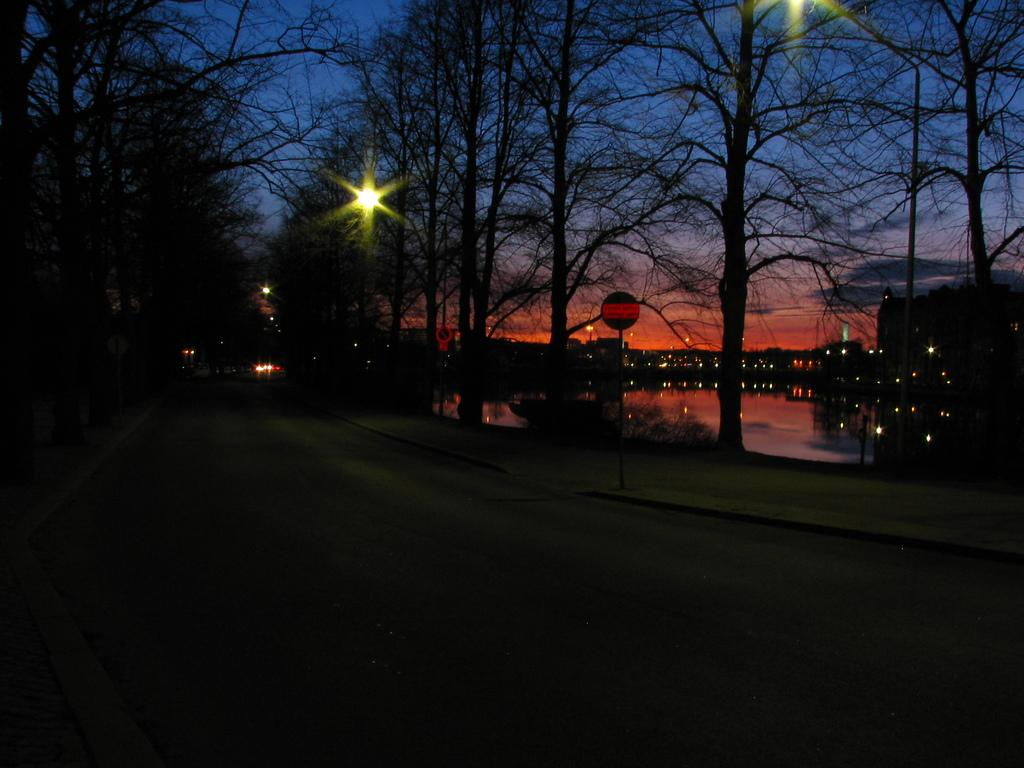What is the main feature of the image? There is a road in the image. What else can be seen besides the road? There is a board on a pole and lights visible in the image. What is visible in the background of the image? There are trees in the background of the image. What type of sweater is being knitted by the pest in the image? There is no sweater or pest present in the image. 